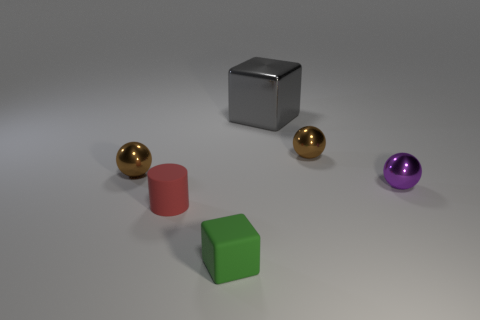Subtract all tiny brown metallic spheres. How many spheres are left? 1 Add 3 small rubber objects. How many objects exist? 9 Subtract all cylinders. How many objects are left? 5 Subtract all large metal cubes. Subtract all matte blocks. How many objects are left? 4 Add 6 purple things. How many purple things are left? 7 Add 6 red matte cylinders. How many red matte cylinders exist? 7 Subtract 0 blue cylinders. How many objects are left? 6 